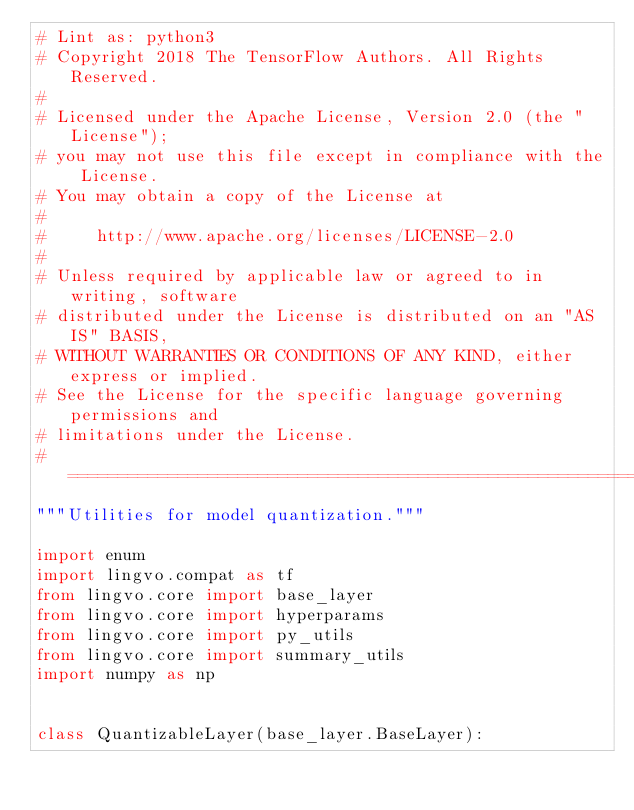<code> <loc_0><loc_0><loc_500><loc_500><_Python_># Lint as: python3
# Copyright 2018 The TensorFlow Authors. All Rights Reserved.
#
# Licensed under the Apache License, Version 2.0 (the "License");
# you may not use this file except in compliance with the License.
# You may obtain a copy of the License at
#
#     http://www.apache.org/licenses/LICENSE-2.0
#
# Unless required by applicable law or agreed to in writing, software
# distributed under the License is distributed on an "AS IS" BASIS,
# WITHOUT WARRANTIES OR CONDITIONS OF ANY KIND, either express or implied.
# See the License for the specific language governing permissions and
# limitations under the License.
# ==============================================================================
"""Utilities for model quantization."""

import enum
import lingvo.compat as tf
from lingvo.core import base_layer
from lingvo.core import hyperparams
from lingvo.core import py_utils
from lingvo.core import summary_utils
import numpy as np


class QuantizableLayer(base_layer.BaseLayer):</code> 